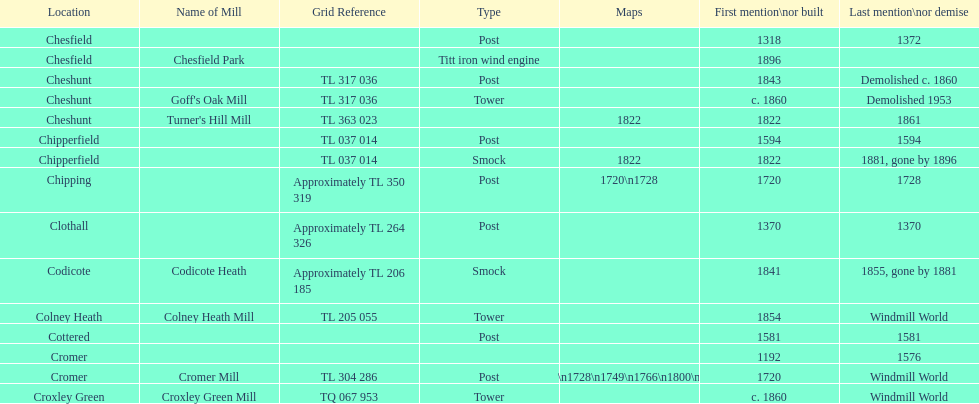How many locations have or had at least 2 windmills? 4. 